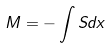Convert formula to latex. <formula><loc_0><loc_0><loc_500><loc_500>M = - \int S d x</formula> 